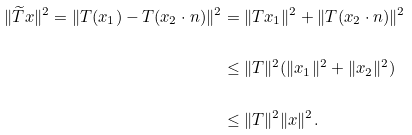Convert formula to latex. <formula><loc_0><loc_0><loc_500><loc_500>\| \widetilde { T } x \| ^ { 2 } = \| { T } ( x _ { 1 } ) - { T } ( x _ { 2 } \cdot n ) \| ^ { 2 } & = \| T x _ { 1 } \| ^ { 2 } + \| T ( x _ { 2 } \cdot n ) \| ^ { 2 } \\ & \leq \| T \| ^ { 2 } ( \| x _ { 1 } \| ^ { 2 } + \| x _ { 2 } \| ^ { 2 } ) \\ & \leq \| T \| ^ { 2 } \| x \| ^ { 2 } .</formula> 